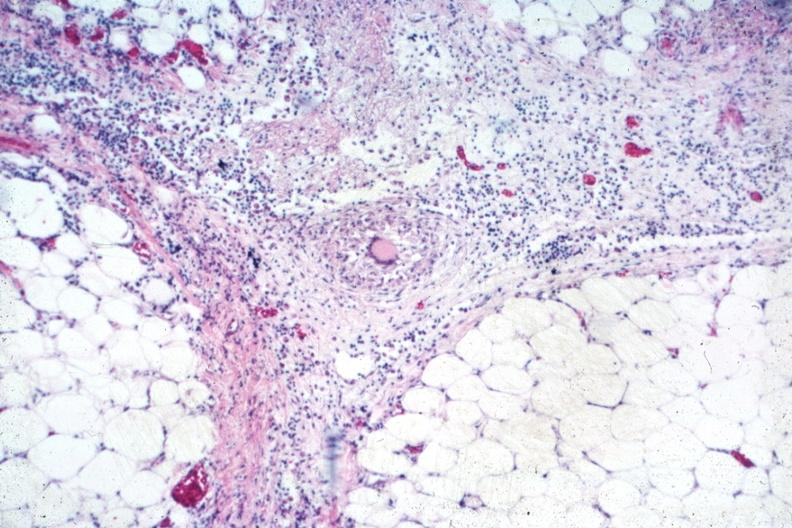what is present?
Answer the question using a single word or phrase. Abdomen 